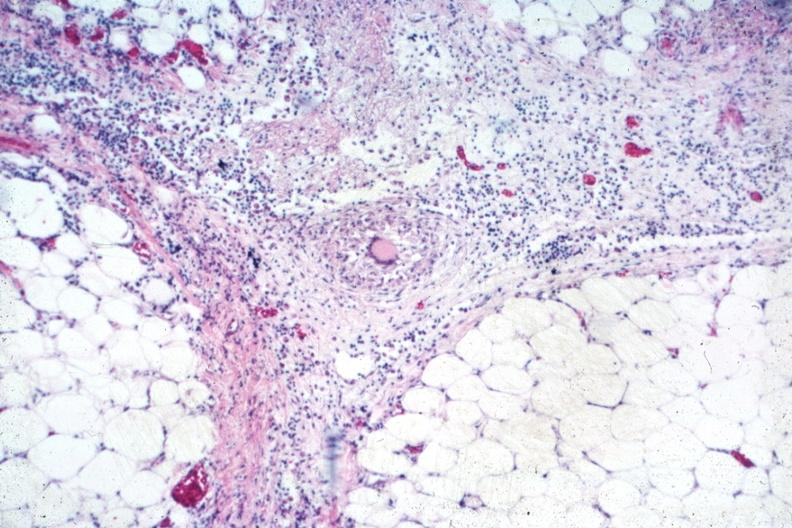what is present?
Answer the question using a single word or phrase. Abdomen 